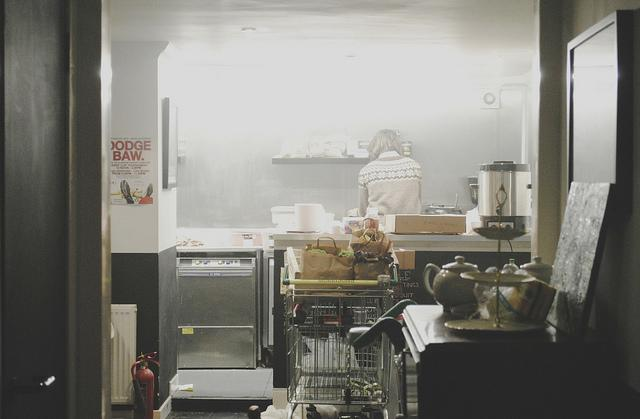What is the woman doing? cooking 